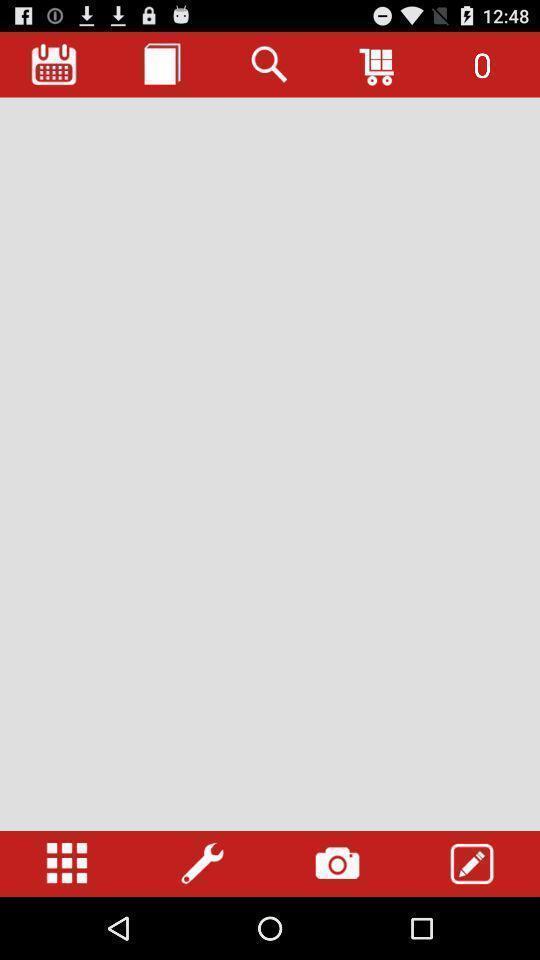Give me a summary of this screen capture. Informative page about various features. 